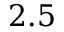<formula> <loc_0><loc_0><loc_500><loc_500>2 . 5</formula> 